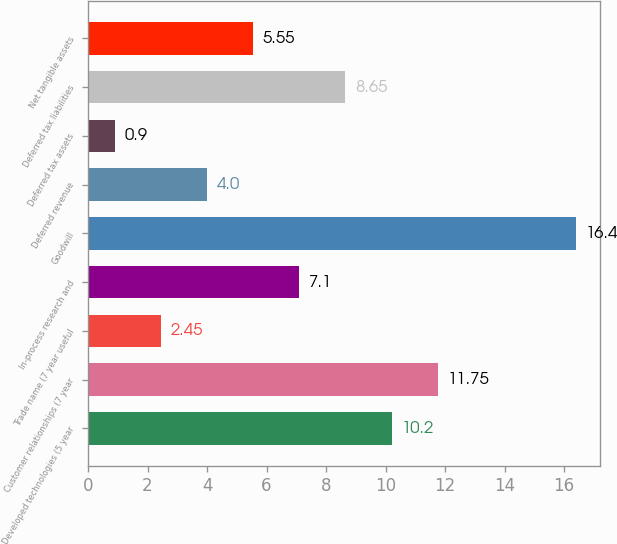Convert chart. <chart><loc_0><loc_0><loc_500><loc_500><bar_chart><fcel>Developed technologies (5 year<fcel>Customer relationships (7 year<fcel>Trade name (7 year useful<fcel>In-process research and<fcel>Goodwill<fcel>Deferred revenue<fcel>Deferred tax assets<fcel>Deferred tax liabilities<fcel>Net tangible assets<nl><fcel>10.2<fcel>11.75<fcel>2.45<fcel>7.1<fcel>16.4<fcel>4<fcel>0.9<fcel>8.65<fcel>5.55<nl></chart> 